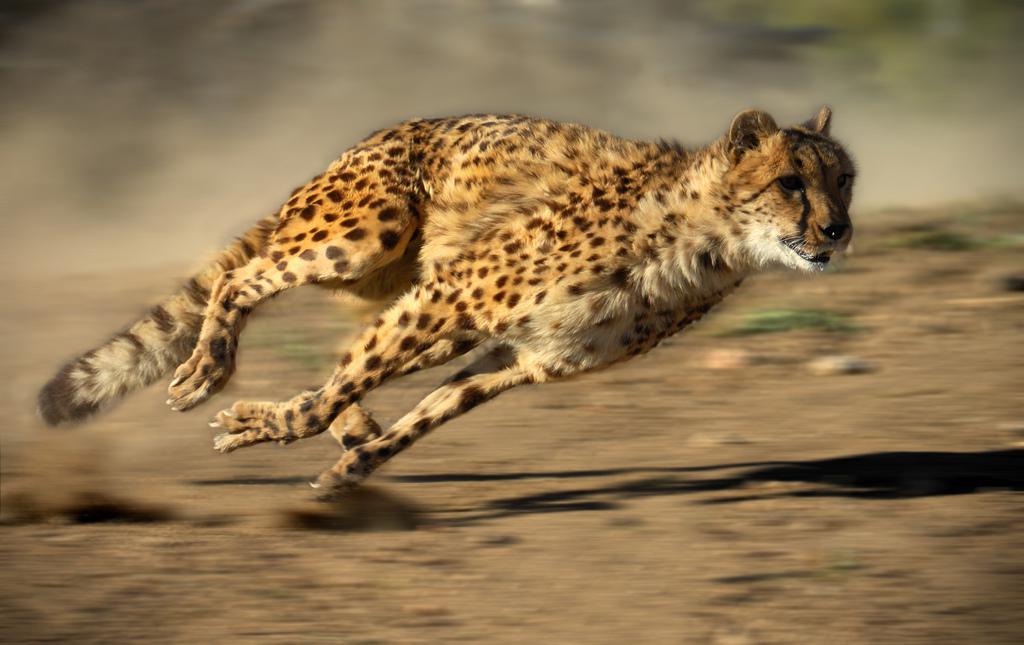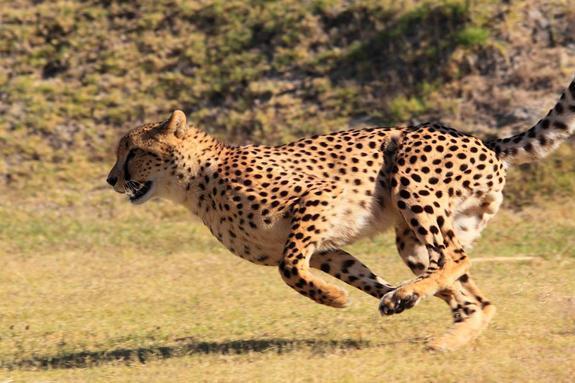The first image is the image on the left, the second image is the image on the right. Given the left and right images, does the statement "An image contains a cheetah facing towards the left." hold true? Answer yes or no. Yes. The first image is the image on the left, the second image is the image on the right. Analyze the images presented: Is the assertion "Each image shows a cheetah in a running pose, and one image shows a cheetah bounding rightward over green grass." valid? Answer yes or no. No. 